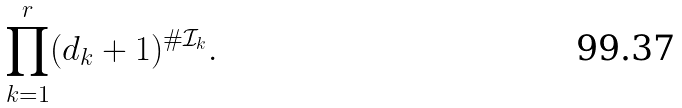Convert formula to latex. <formula><loc_0><loc_0><loc_500><loc_500>\prod _ { k = 1 } ^ { r } ( d _ { k } + 1 ) ^ { \# \mathcal { I } _ { k } } .</formula> 